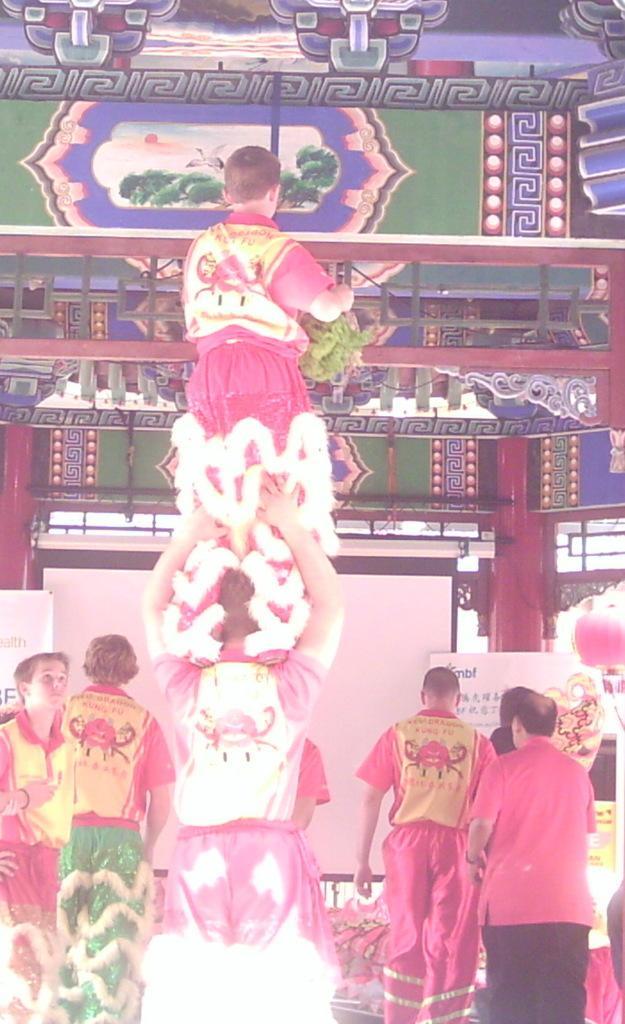Describe this image in one or two sentences. There are some person standing as we can see at the bottom of this image and there is a wall poster as we can see at the top of this image. 